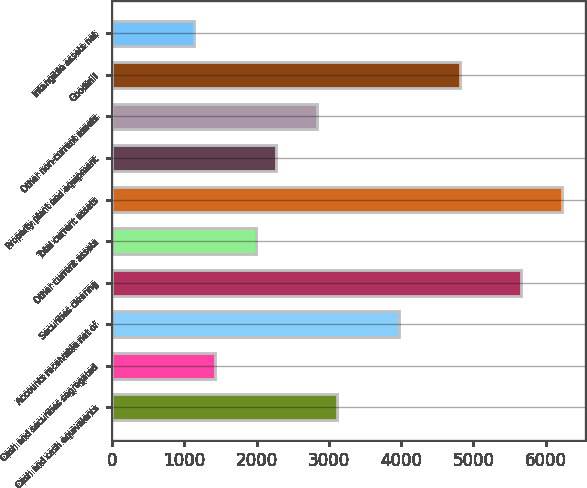<chart> <loc_0><loc_0><loc_500><loc_500><bar_chart><fcel>Cash and cash equivalents<fcel>Cash and securities segregated<fcel>Accounts receivable net of<fcel>Securities clearing<fcel>Other current assets<fcel>Total current assets<fcel>Property plant and equipment<fcel>Other non-current assets<fcel>Goodwill<fcel>Intangible assets net<nl><fcel>3116.82<fcel>1417.5<fcel>3966.48<fcel>5665.8<fcel>1983.94<fcel>6232.24<fcel>2267.16<fcel>2833.6<fcel>4816.14<fcel>1134.28<nl></chart> 